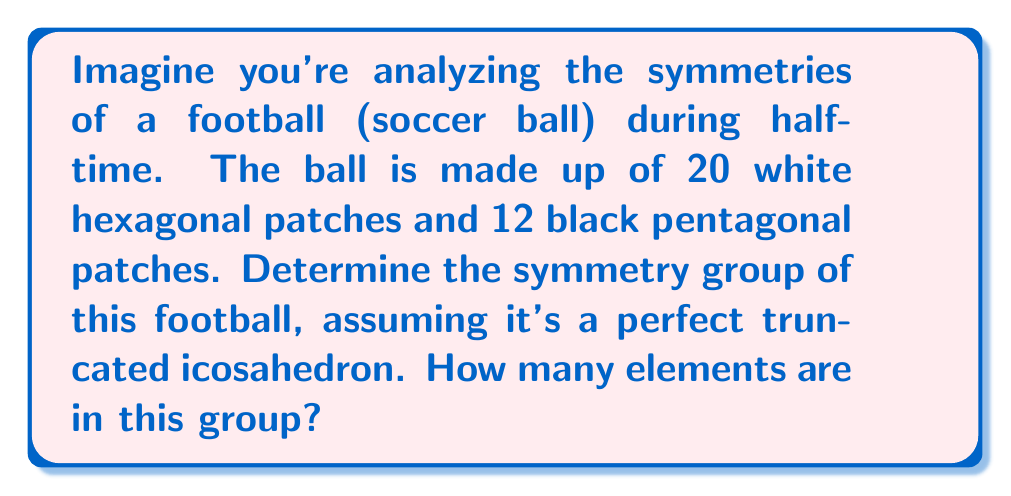Show me your answer to this math problem. Let's approach this step-by-step:

1) First, we need to recognize that a standard football (soccer ball) is shaped like a truncated icosahedron.

2) The symmetry group of a truncated icosahedron is the same as that of a regular icosahedron, which is the icosahedral group.

3) The icosahedral group, also known as $A_5$, is a subgroup of the alternating group on 5 elements.

4) To determine the number of elements in this group, we can consider the rotational symmetries:
   
   a) 15 rotations of order 2 (through the midpoints of edges)
   b) 20 rotations of order 3 (through the centers of faces)
   c) 12 rotations of order 5 (through the vertices)
   d) The identity element

5) The total number of elements is thus:

   $$1 + 15 + 20 \cdot 2 + 12 \cdot 4 = 60$$

   Here's why:
   - 1 identity element
   - 15 rotations of order 2
   - 20 rotations of order 3, each contributes 2 non-identity elements
   - 12 rotations of order 5, each contributes 4 non-identity elements

6) Therefore, the symmetry group of the football is isomorphic to $A_5$, which has 60 elements.
Answer: The symmetry group of the football (truncated icosahedron) is the icosahedral group, isomorphic to $A_5$, with 60 elements. 